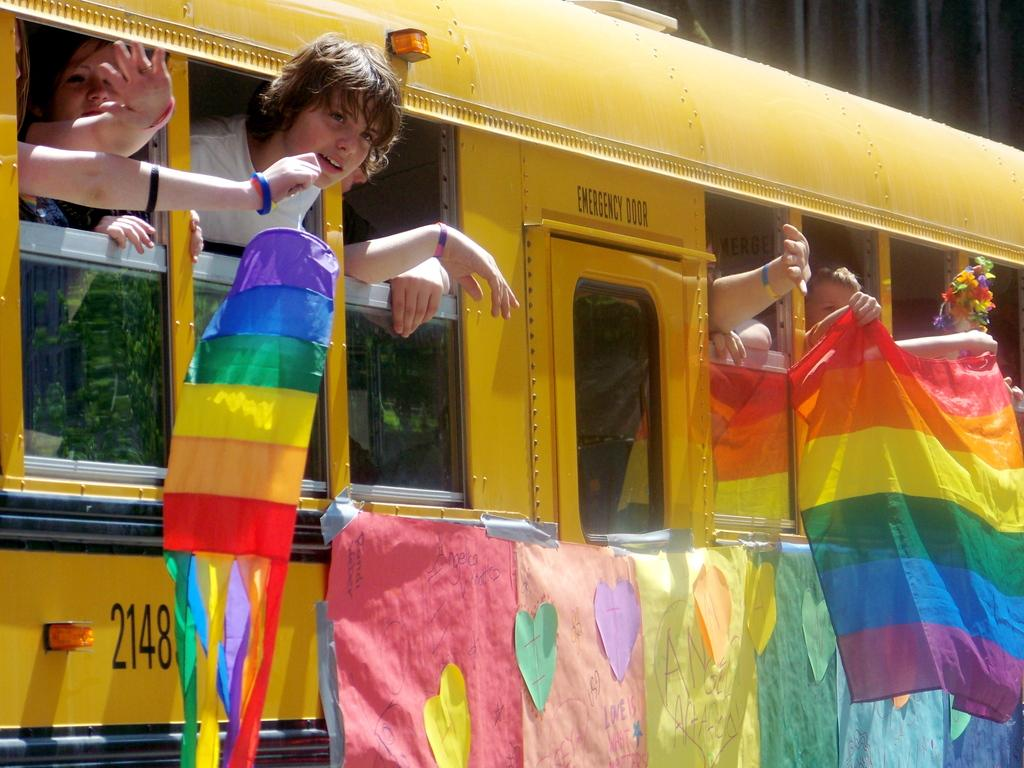What is the main subject of the image? The main subject of the image is a bus. What color is the bus? The bus is yellow. What are the people on the bus doing? The people are sticking their heads out of the bus window and playing with objects. Can you tell me how many umbrellas are being used by the people during the rainstorm in the image? There is no rainstorm present in the image, and therefore no umbrellas are being used. What type of cap is the person wearing in the image? There is no cap visible in the image. 